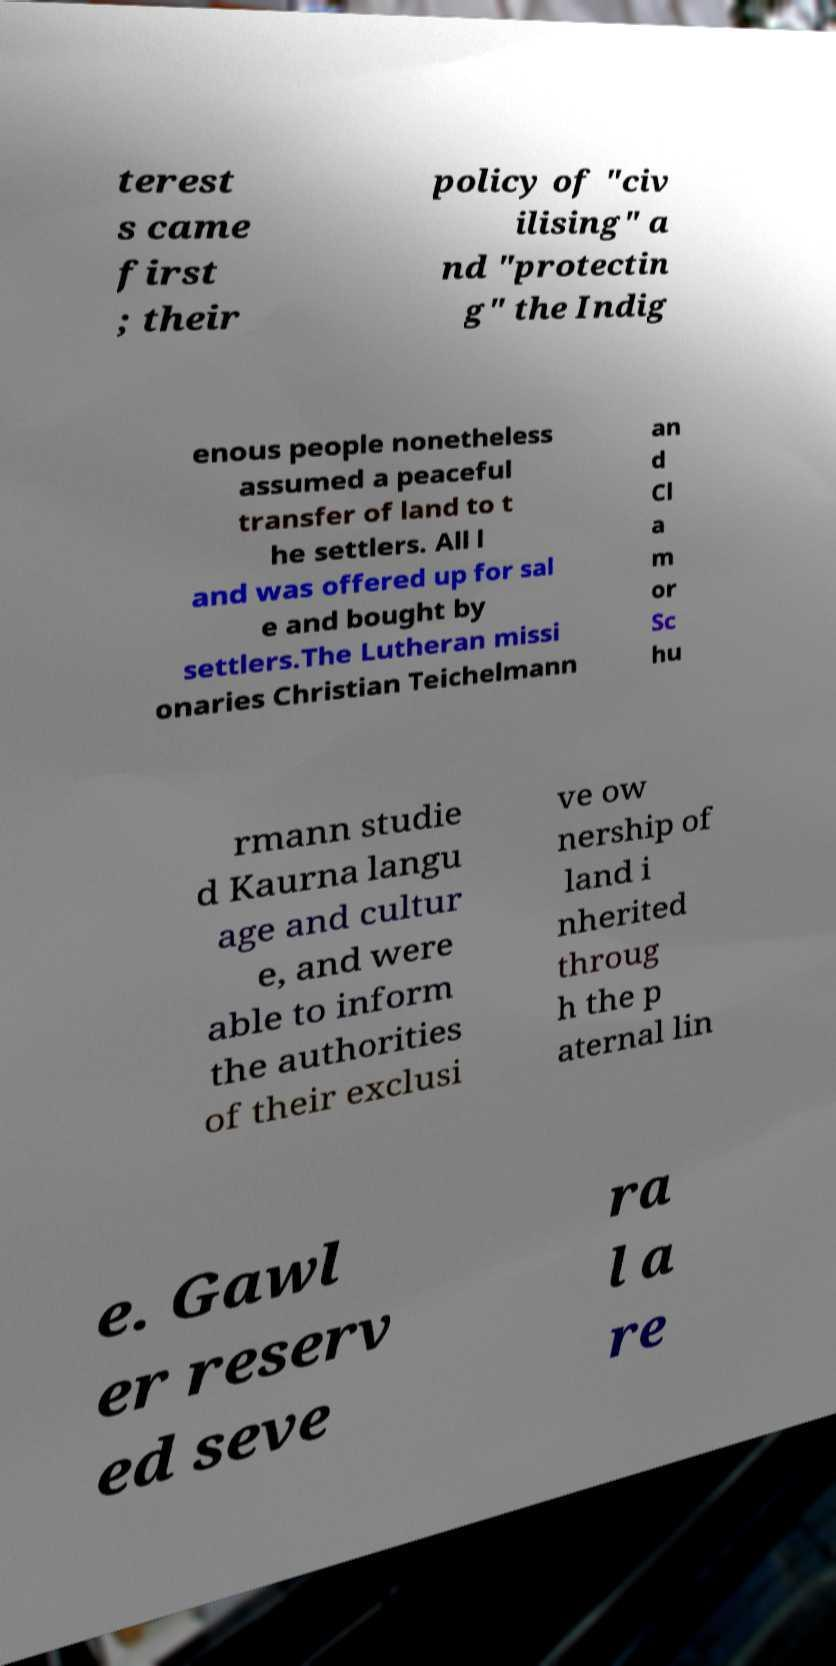Could you extract and type out the text from this image? terest s came first ; their policy of "civ ilising" a nd "protectin g" the Indig enous people nonetheless assumed a peaceful transfer of land to t he settlers. All l and was offered up for sal e and bought by settlers.The Lutheran missi onaries Christian Teichelmann an d Cl a m or Sc hu rmann studie d Kaurna langu age and cultur e, and were able to inform the authorities of their exclusi ve ow nership of land i nherited throug h the p aternal lin e. Gawl er reserv ed seve ra l a re 